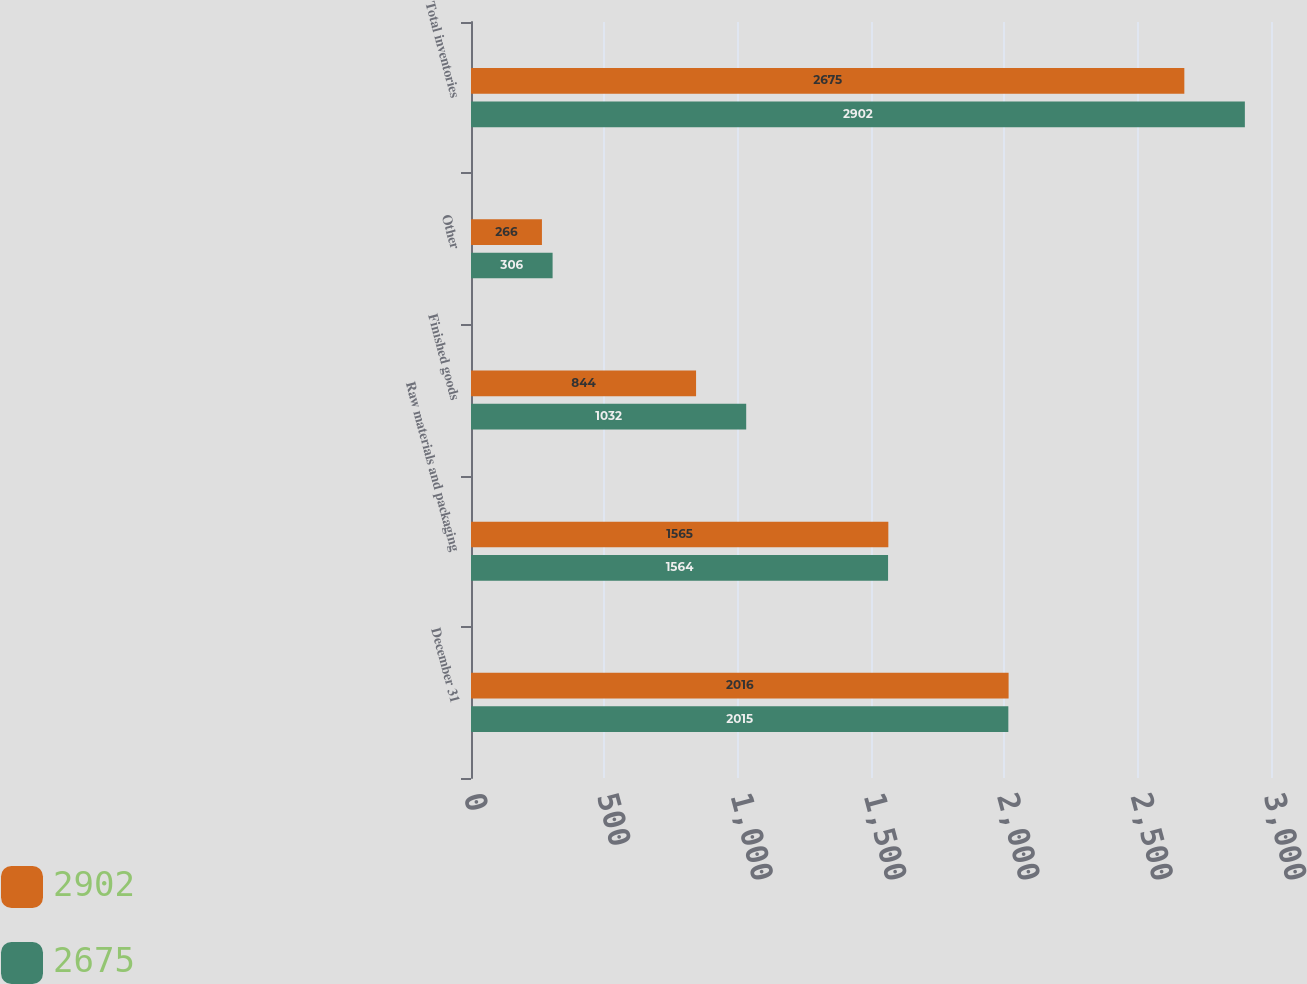Convert chart to OTSL. <chart><loc_0><loc_0><loc_500><loc_500><stacked_bar_chart><ecel><fcel>December 31<fcel>Raw materials and packaging<fcel>Finished goods<fcel>Other<fcel>Total inventories<nl><fcel>2902<fcel>2016<fcel>1565<fcel>844<fcel>266<fcel>2675<nl><fcel>2675<fcel>2015<fcel>1564<fcel>1032<fcel>306<fcel>2902<nl></chart> 